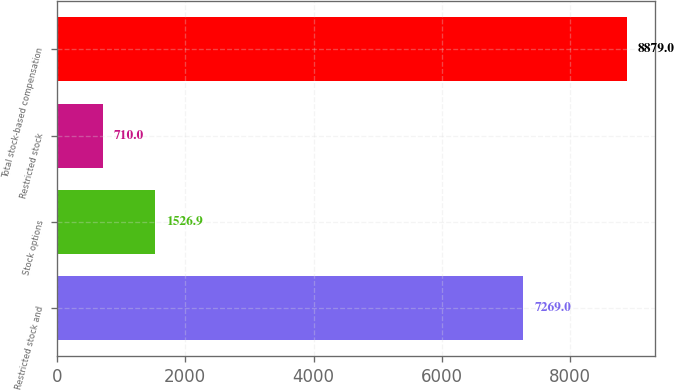<chart> <loc_0><loc_0><loc_500><loc_500><bar_chart><fcel>Restricted stock and<fcel>Stock options<fcel>Restricted stock<fcel>Total stock-based compensation<nl><fcel>7269<fcel>1526.9<fcel>710<fcel>8879<nl></chart> 